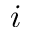Convert formula to latex. <formula><loc_0><loc_0><loc_500><loc_500>i</formula> 